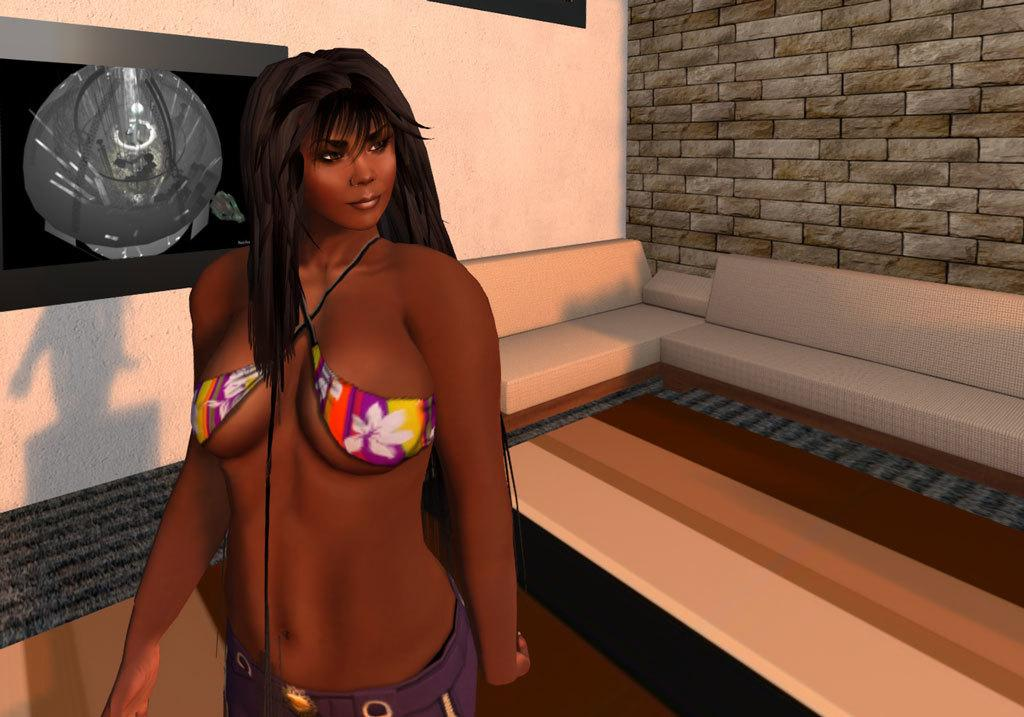What type of image is being described? The image is an animated image. Who or what is the main subject in the image? There is a woman in the image. What can be seen in the background of the image? There is a wall, a screen, and some sofas in the background of the image. Are there any other objects visible in the background? Yes, there are some objects in the background of the image. What type of brick is being used to build the wall in the image? There is no mention of bricks in the image, as the wall is part of an animated scene. Can you see a goat in the image? No, there is no goat present in the image. 